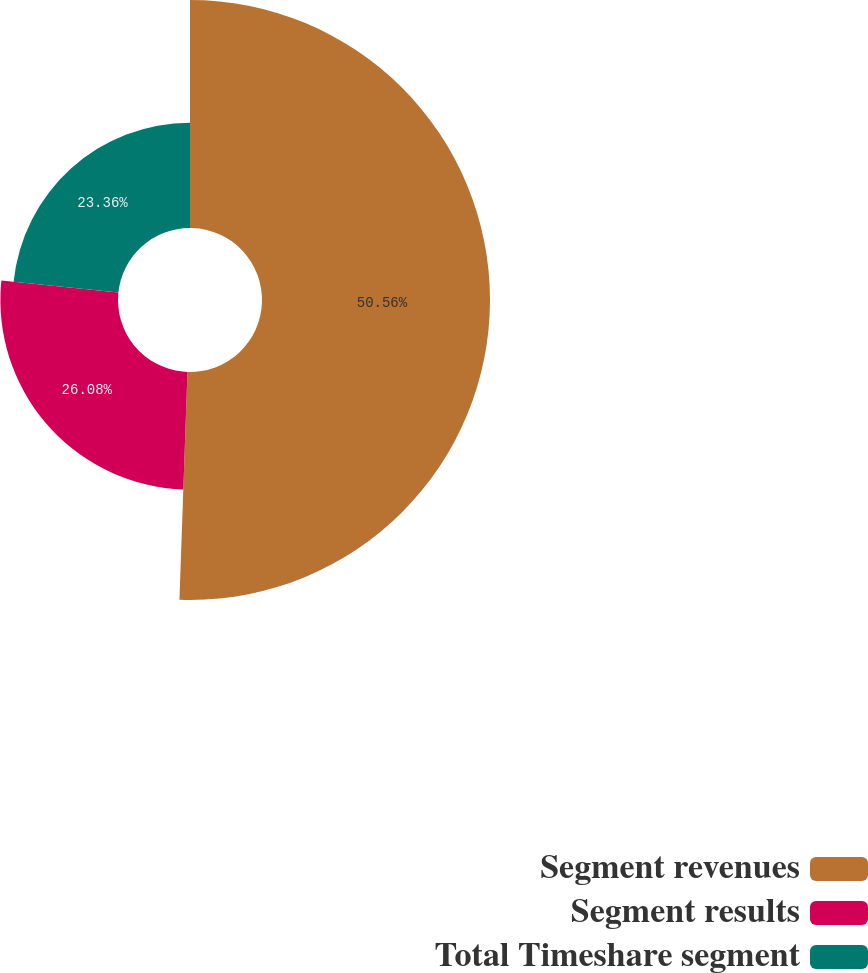Convert chart. <chart><loc_0><loc_0><loc_500><loc_500><pie_chart><fcel>Segment revenues<fcel>Segment results<fcel>Total Timeshare segment<nl><fcel>50.56%<fcel>26.08%<fcel>23.36%<nl></chart> 